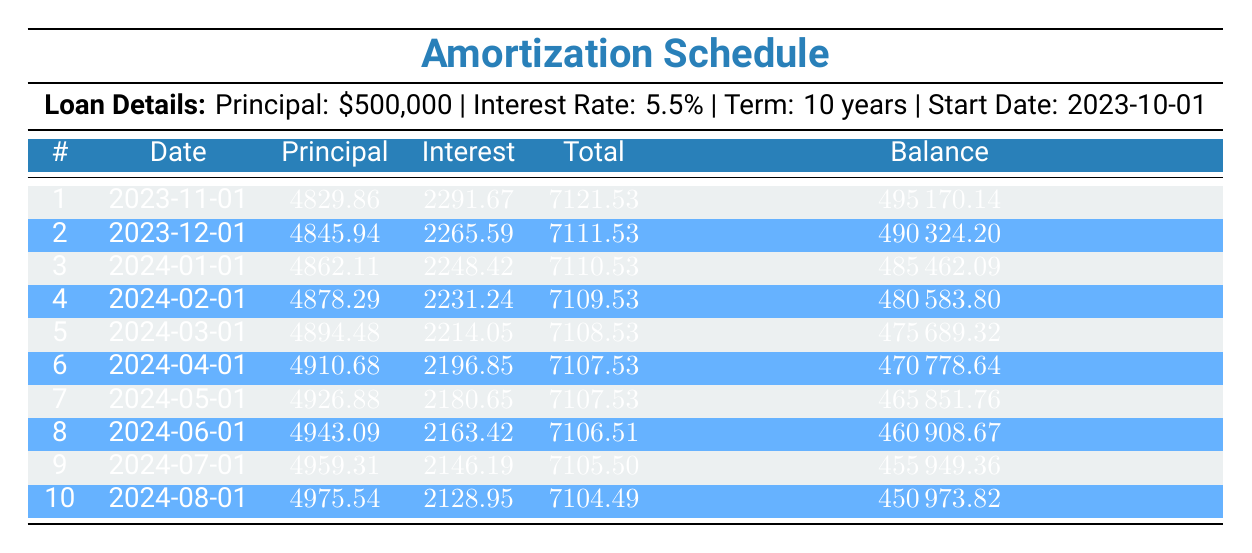What is the total payment for the first month? The first month’s total payment amount is listed in the table under the "Total" column for payment number 1, which is 7121.53.
Answer: 7121.53 How much principal is paid off in the fourth payment? Looking at the "Principal" column for payment number 4, the principal payment is 4878.29.
Answer: 4878.29 What is the interest payment in the second month? The interest payment for the second month can be found in the "Interest" column for payment number 2, which is 2265.59.
Answer: 2265.59 Is the total payment for month 10 greater than 7100? The total payment for month 10 is 7104.49, which is greater than 7100. Therefore, the answer is yes.
Answer: Yes What is the average principal payment over the first five months? The sum of the principal payments for the first five months is (4829.86 + 4845.94 + 4862.11 + 4878.29 + 4894.48) = 24110.68. The average is calculated as 24110.68 divided by 5, which equals 4822.136.
Answer: 4822.14 How much is the remaining balance after the sixth payment? The remaining balance after the sixth payment is listed in the "Balance" column for payment number 6, which is 470778.64.
Answer: 470778.64 What is the total amount paid towards interest in the first three payments? To find the total interest paid in the first three payments, we add the interest payments: (2291.67 + 2265.59 + 2248.42) = 6805.68.
Answer: 6805.68 Is the principal payment increasing each month? By comparing the "Principal" column values for each month, we see that they are increasing: 4829.86, 4845.94, 4862.11, 4878.29, and so on, indicating a continued increase.
Answer: Yes What is the change in remaining balance from the first payment to the last payment listed? The remaining balance after the first payment is 495170.14, and after the last payment (10th) it is 450973.82. The change is calculated as 495170.14 - 450973.82 = 44216.32.
Answer: 44216.32 